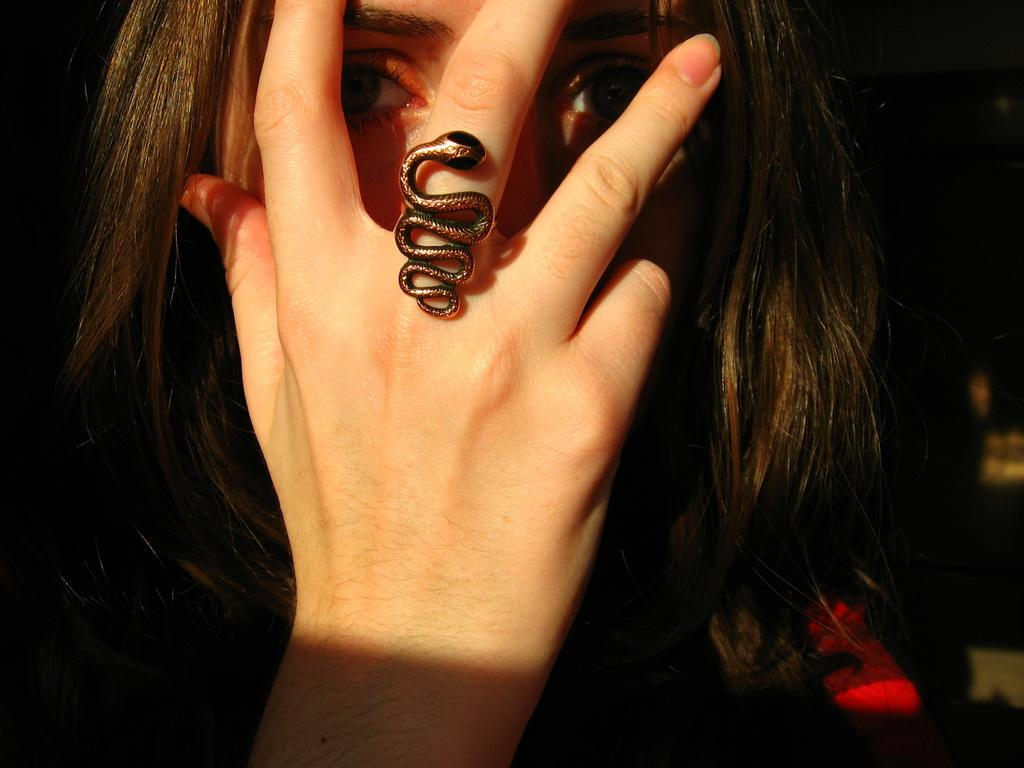Who is present in the image? There is a woman in the image. What is the woman doing with her hand? The woman is covering her face with a hand. Can you describe any jewelry the woman is wearing? There is a snake ring on the woman's finger. What type of umbrella is the woman holding in the image? There is no umbrella present in the image. 